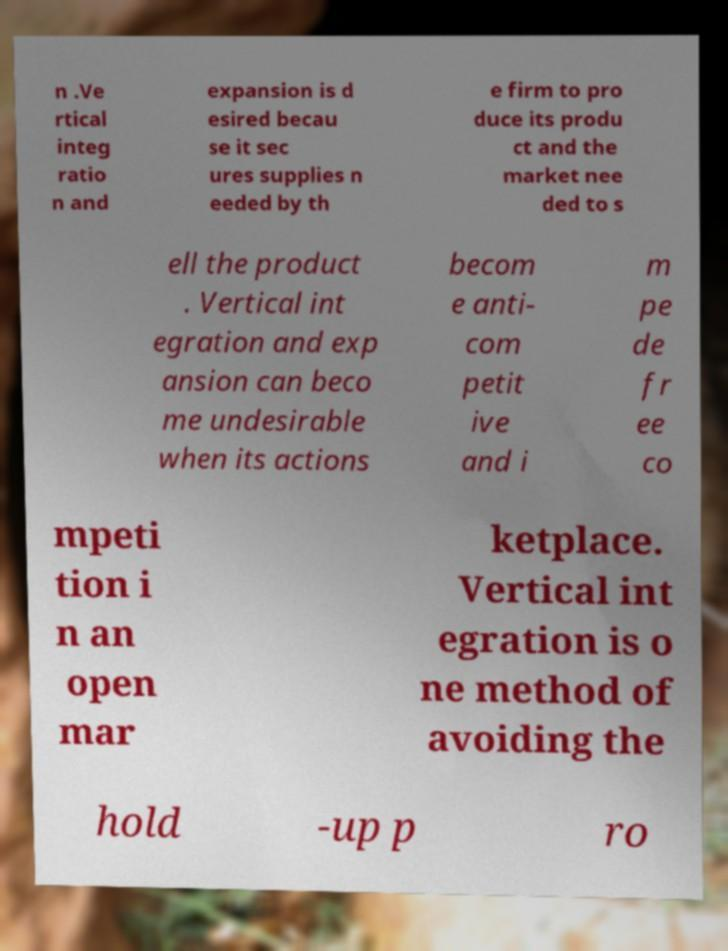What messages or text are displayed in this image? I need them in a readable, typed format. n .Ve rtical integ ratio n and expansion is d esired becau se it sec ures supplies n eeded by th e firm to pro duce its produ ct and the market nee ded to s ell the product . Vertical int egration and exp ansion can beco me undesirable when its actions becom e anti- com petit ive and i m pe de fr ee co mpeti tion i n an open mar ketplace. Vertical int egration is o ne method of avoiding the hold -up p ro 